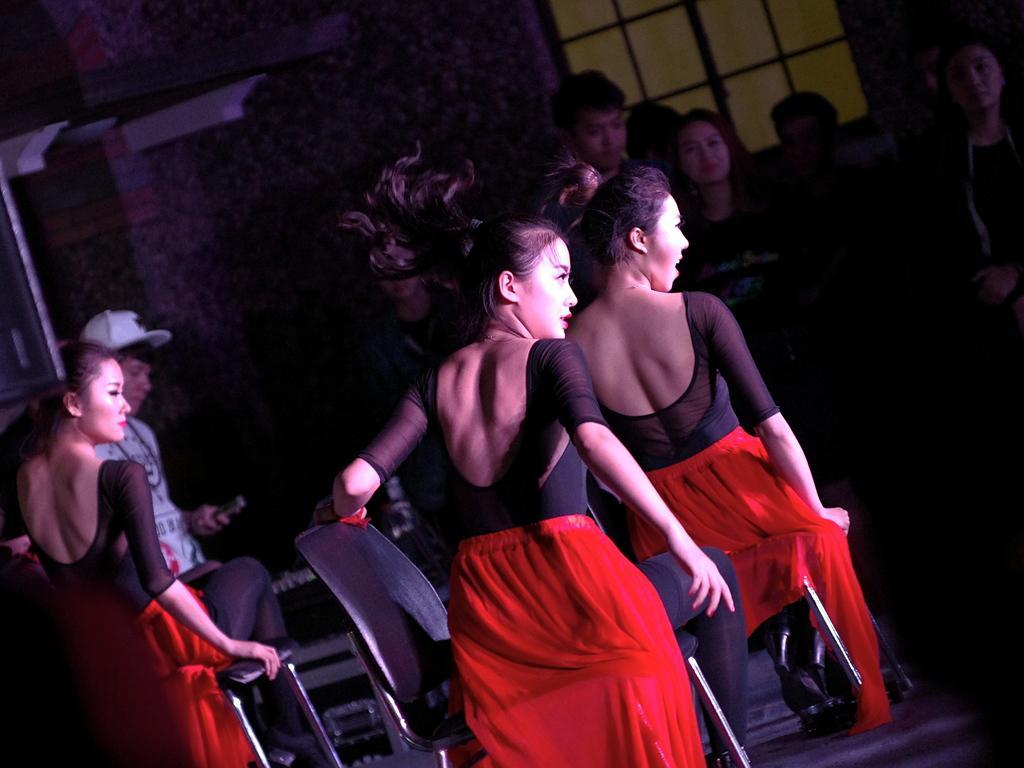Can you describe this image briefly? In this image there are three women sitting on the chair, there are group of persons stand, there is a person holding an object, there is a wall, there is a window towards the top of the image. 